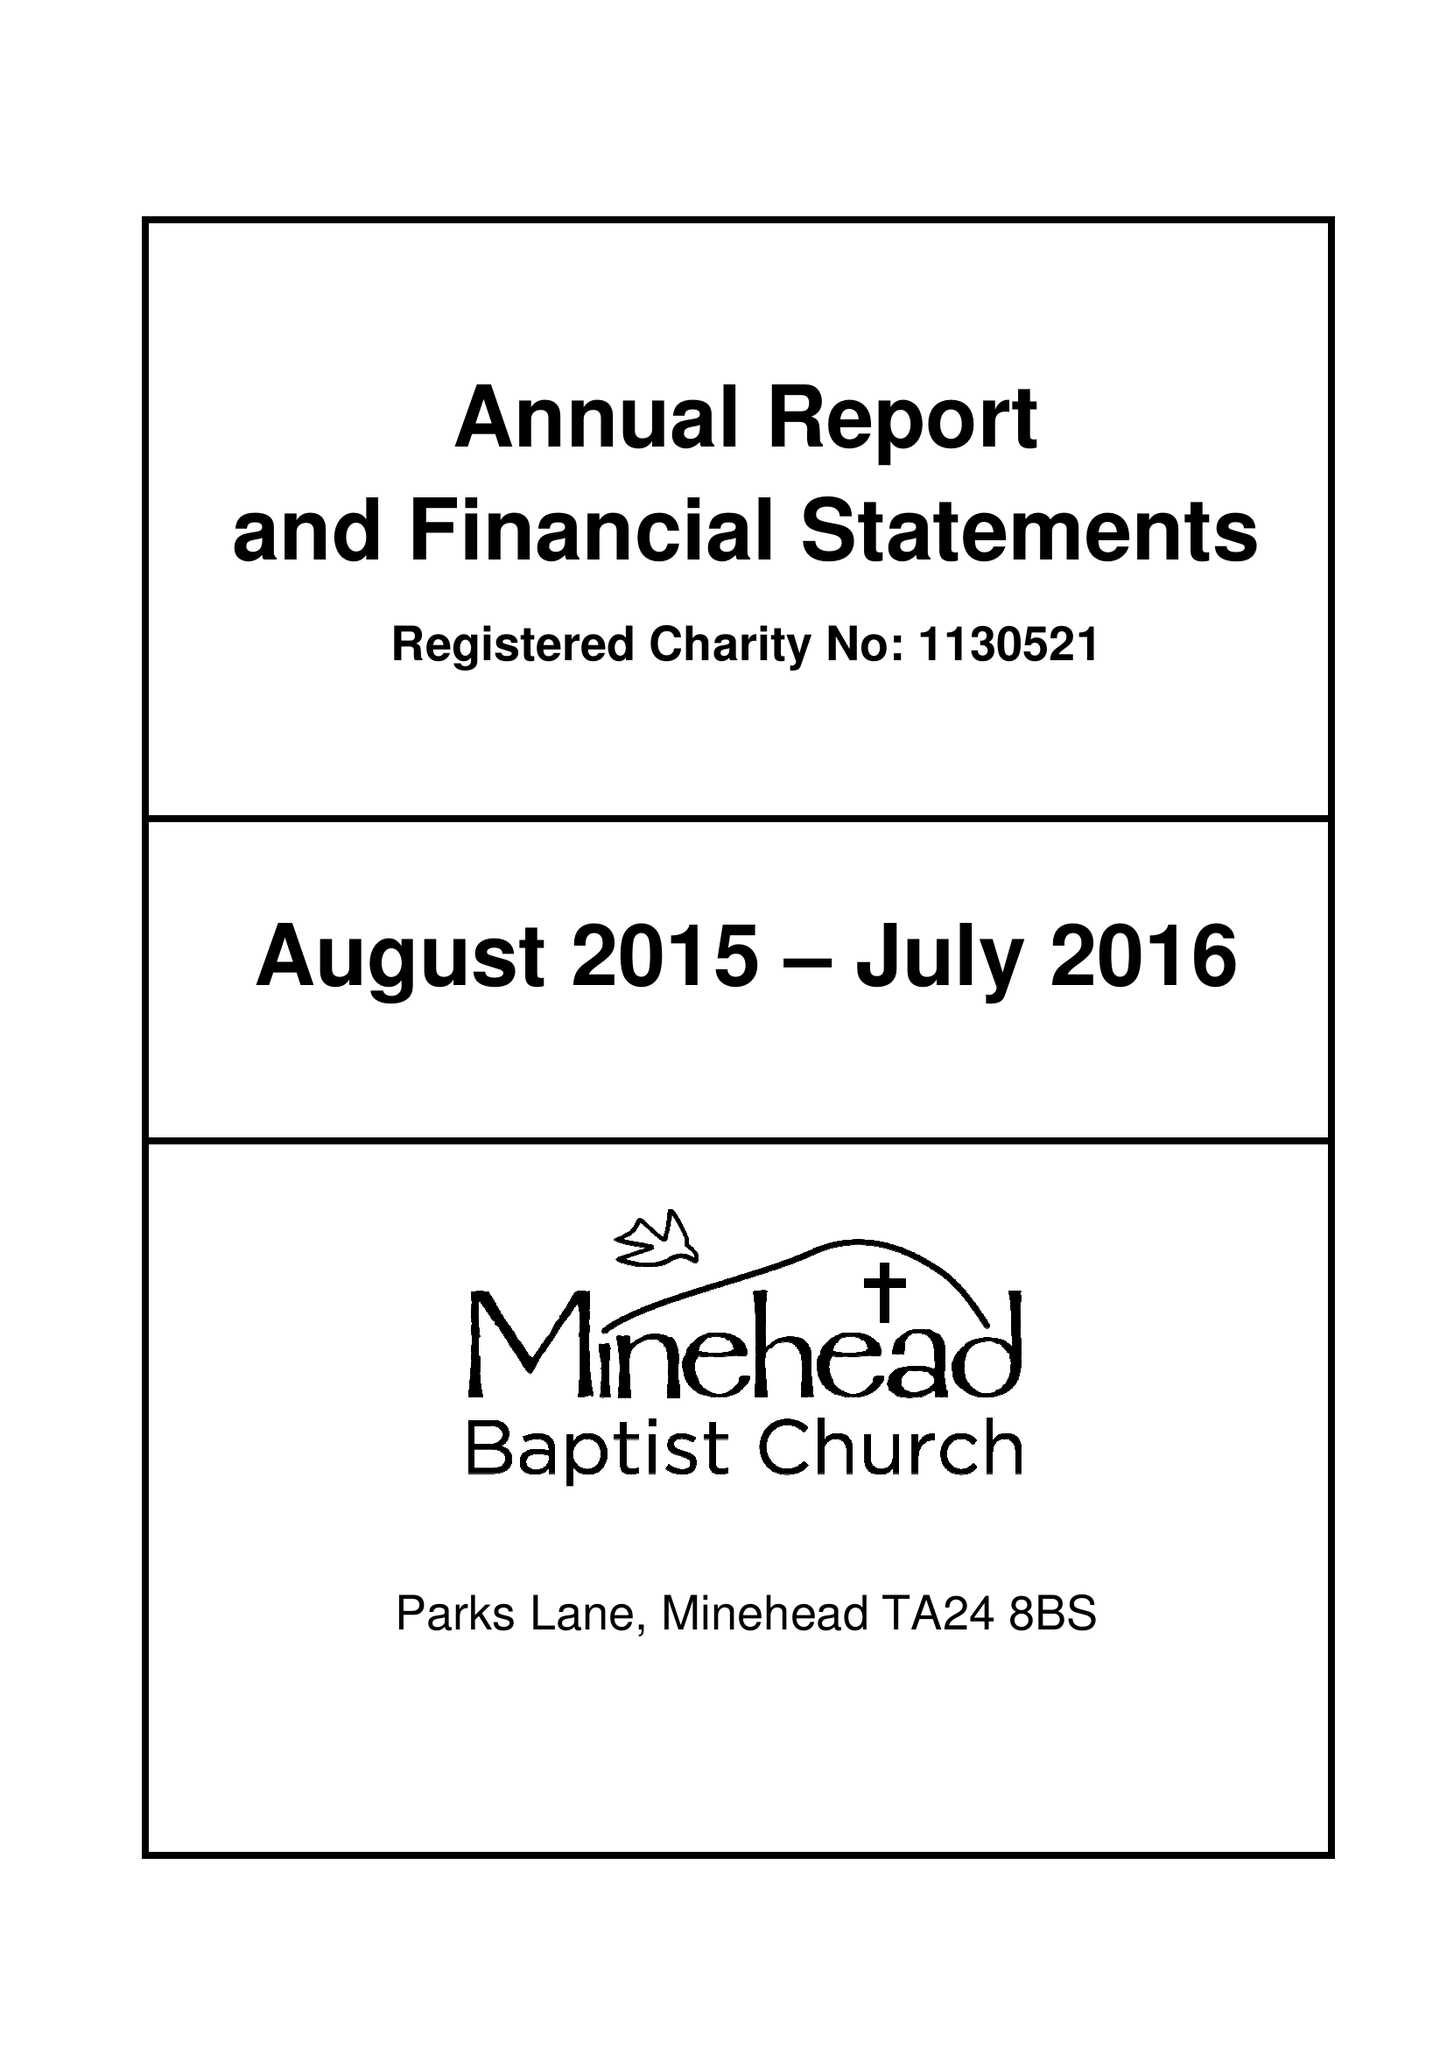What is the value for the income_annually_in_british_pounds?
Answer the question using a single word or phrase. 244159.00 